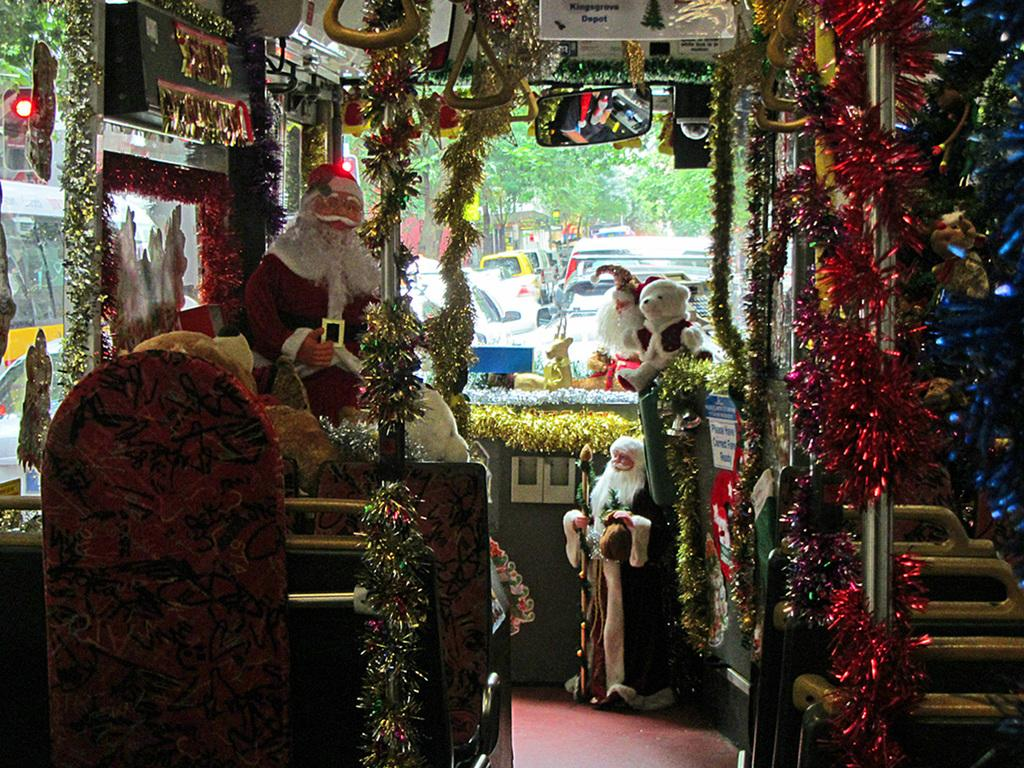What is located in the center of the image? In the center of the image, there are toys, chairs, poles, banners, lights, glass, a mirror, and decorative items. Can you describe the objects in the center of the image? The center of the image contains a mix of toys, chairs, poles, banners, lights, glass, a mirror, and decorative items. What can be seen in the background of the image? In the background of the image, there are trees, poles, and vehicles. How many quarters are visible on the sidewalk in the image? There is no sidewalk or quarters present in the image. What type of jelly is being used to decorate the mirror in the image? There is no jelly present in the image, and the mirror is not being decorated with any jelly. 